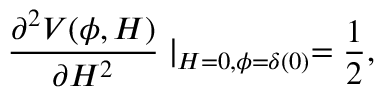<formula> <loc_0><loc_0><loc_500><loc_500>\frac { \partial ^ { 2 } V ( \phi , H ) } { \partial H ^ { 2 } } | _ { H = 0 , \phi = \delta ( 0 ) } = \frac { 1 } { 2 } ,</formula> 